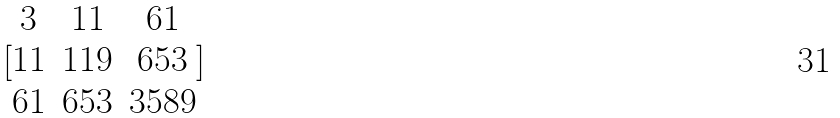<formula> <loc_0><loc_0><loc_500><loc_500>[ \begin{matrix} 3 & 1 1 & 6 1 \\ 1 1 & 1 1 9 & 6 5 3 \\ 6 1 & 6 5 3 & 3 5 8 9 \end{matrix} ]</formula> 